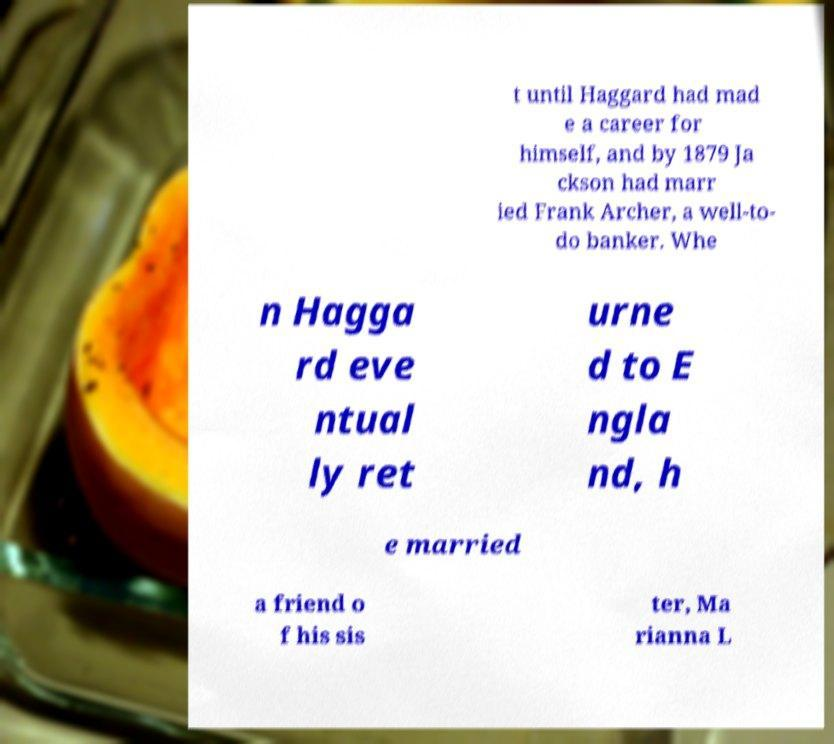There's text embedded in this image that I need extracted. Can you transcribe it verbatim? t until Haggard had mad e a career for himself, and by 1879 Ja ckson had marr ied Frank Archer, a well-to- do banker. Whe n Hagga rd eve ntual ly ret urne d to E ngla nd, h e married a friend o f his sis ter, Ma rianna L 